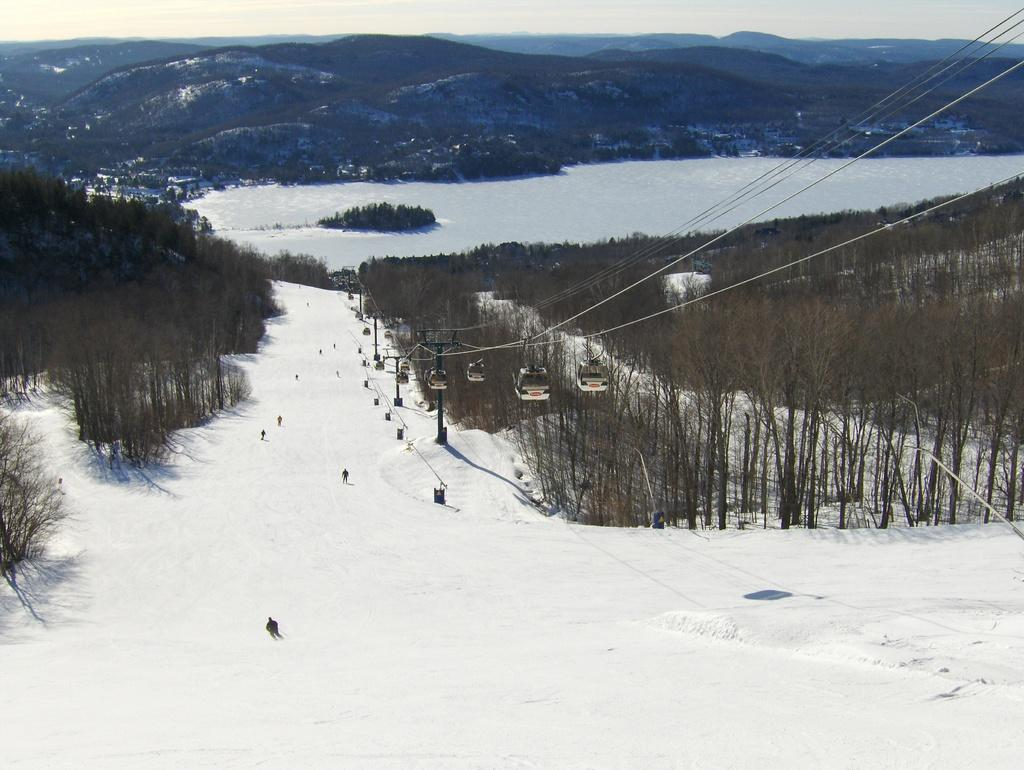What is the primary feature of the landscape in the image? There is snow in the image. What type of natural elements can be seen in the image? There are trees in the image. What man-made structures are visible in the image? The rope ways are visible in the middle of the image. What can be seen in the distance in the image? There are mountains in the background of the image. Where is the shop located in the image? There is no shop present in the image. Can you see any cellars in the image? There are no cellars visible in the image. 